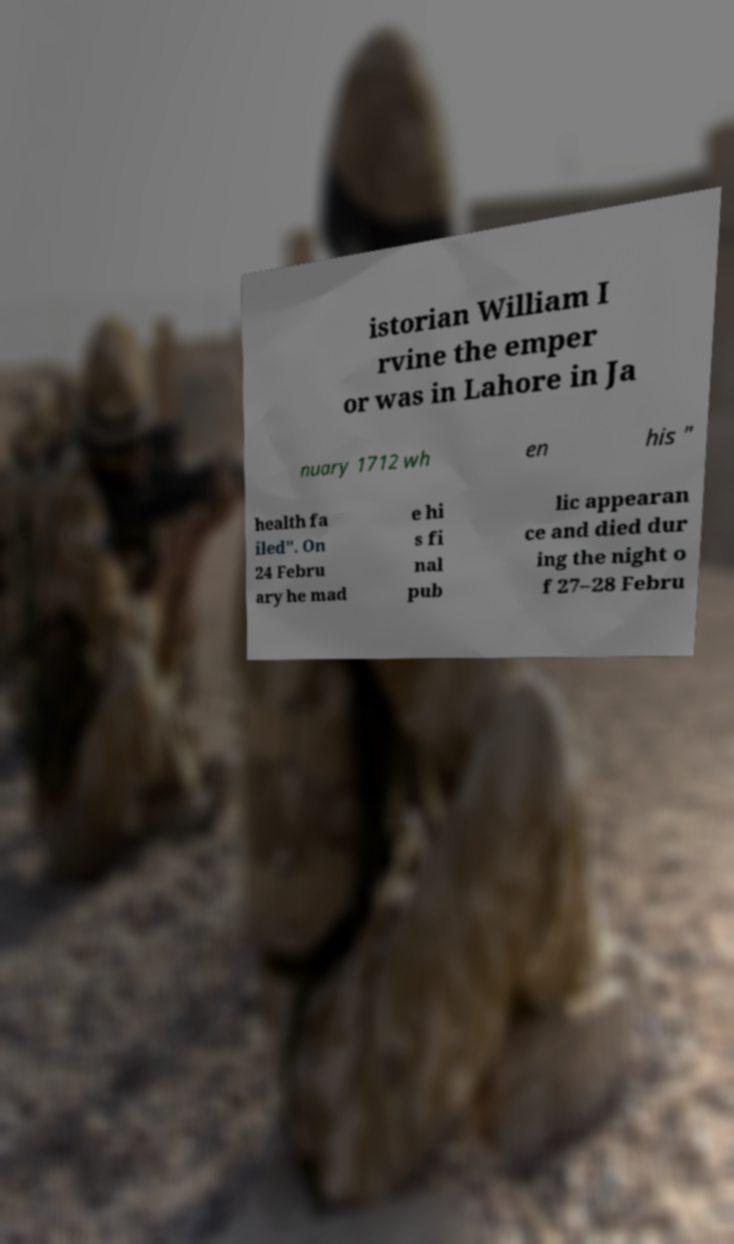For documentation purposes, I need the text within this image transcribed. Could you provide that? istorian William I rvine the emper or was in Lahore in Ja nuary 1712 wh en his " health fa iled". On 24 Febru ary he mad e hi s fi nal pub lic appearan ce and died dur ing the night o f 27–28 Febru 